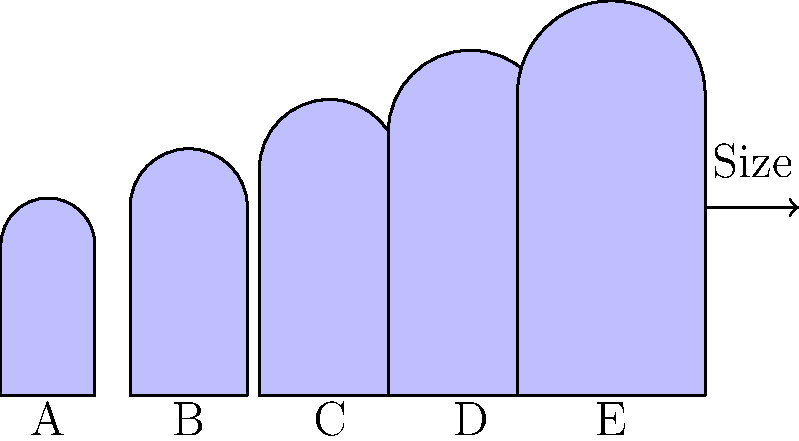As a new mother, you're organizing baby bottles for your premature infant. The pediatrician recommends using bottles of increasing size as your baby grows. Given the set of bottles labeled A to E, arrange them in order from smallest to largest. What is the correct sequence? To solve this problem, we need to compare the sizes of the bottles visually and arrange them from smallest to largest. Let's break it down step-by-step:

1. Observe that the bottles are labeled A, B, C, D, and E from left to right.
2. Compare the heights and widths of the bottles:
   - Bottle A is the shortest and narrowest
   - Bottle B is slightly taller and wider than A
   - Bottle C is taller and wider than B
   - Bottle D is taller and wider than C
   - Bottle E is the tallest and widest

3. The arrow at the right indicates that size increases from left to right.

4. Therefore, the bottles are already arranged in order from smallest to largest.

5. The correct sequence from smallest to largest is: A, B, C, D, E.

This arrangement aligns with the pediatrician's recommendation to use increasingly larger bottles as your premature baby grows and develops.
Answer: A, B, C, D, E 